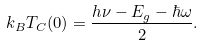Convert formula to latex. <formula><loc_0><loc_0><loc_500><loc_500>k _ { B } T _ { C } ( 0 ) = \frac { h \nu - E _ { g } - \hbar { \omega } } { 2 } .</formula> 